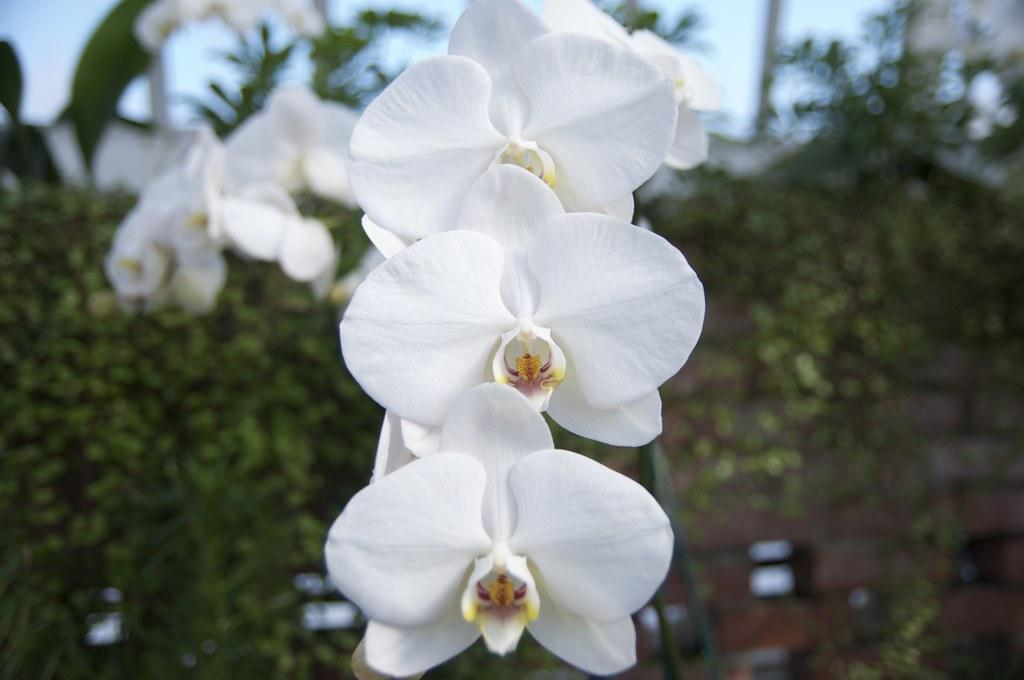What is the main subject of the image? The main subject of the image is a group of flowers. What can be seen in the background of the image? There are trees and the sky visible in the background of the image. How many snakes are slithering through the group of flowers in the image? There are no snakes present in the image; it features a group of flowers and a background with trees and the sky. 